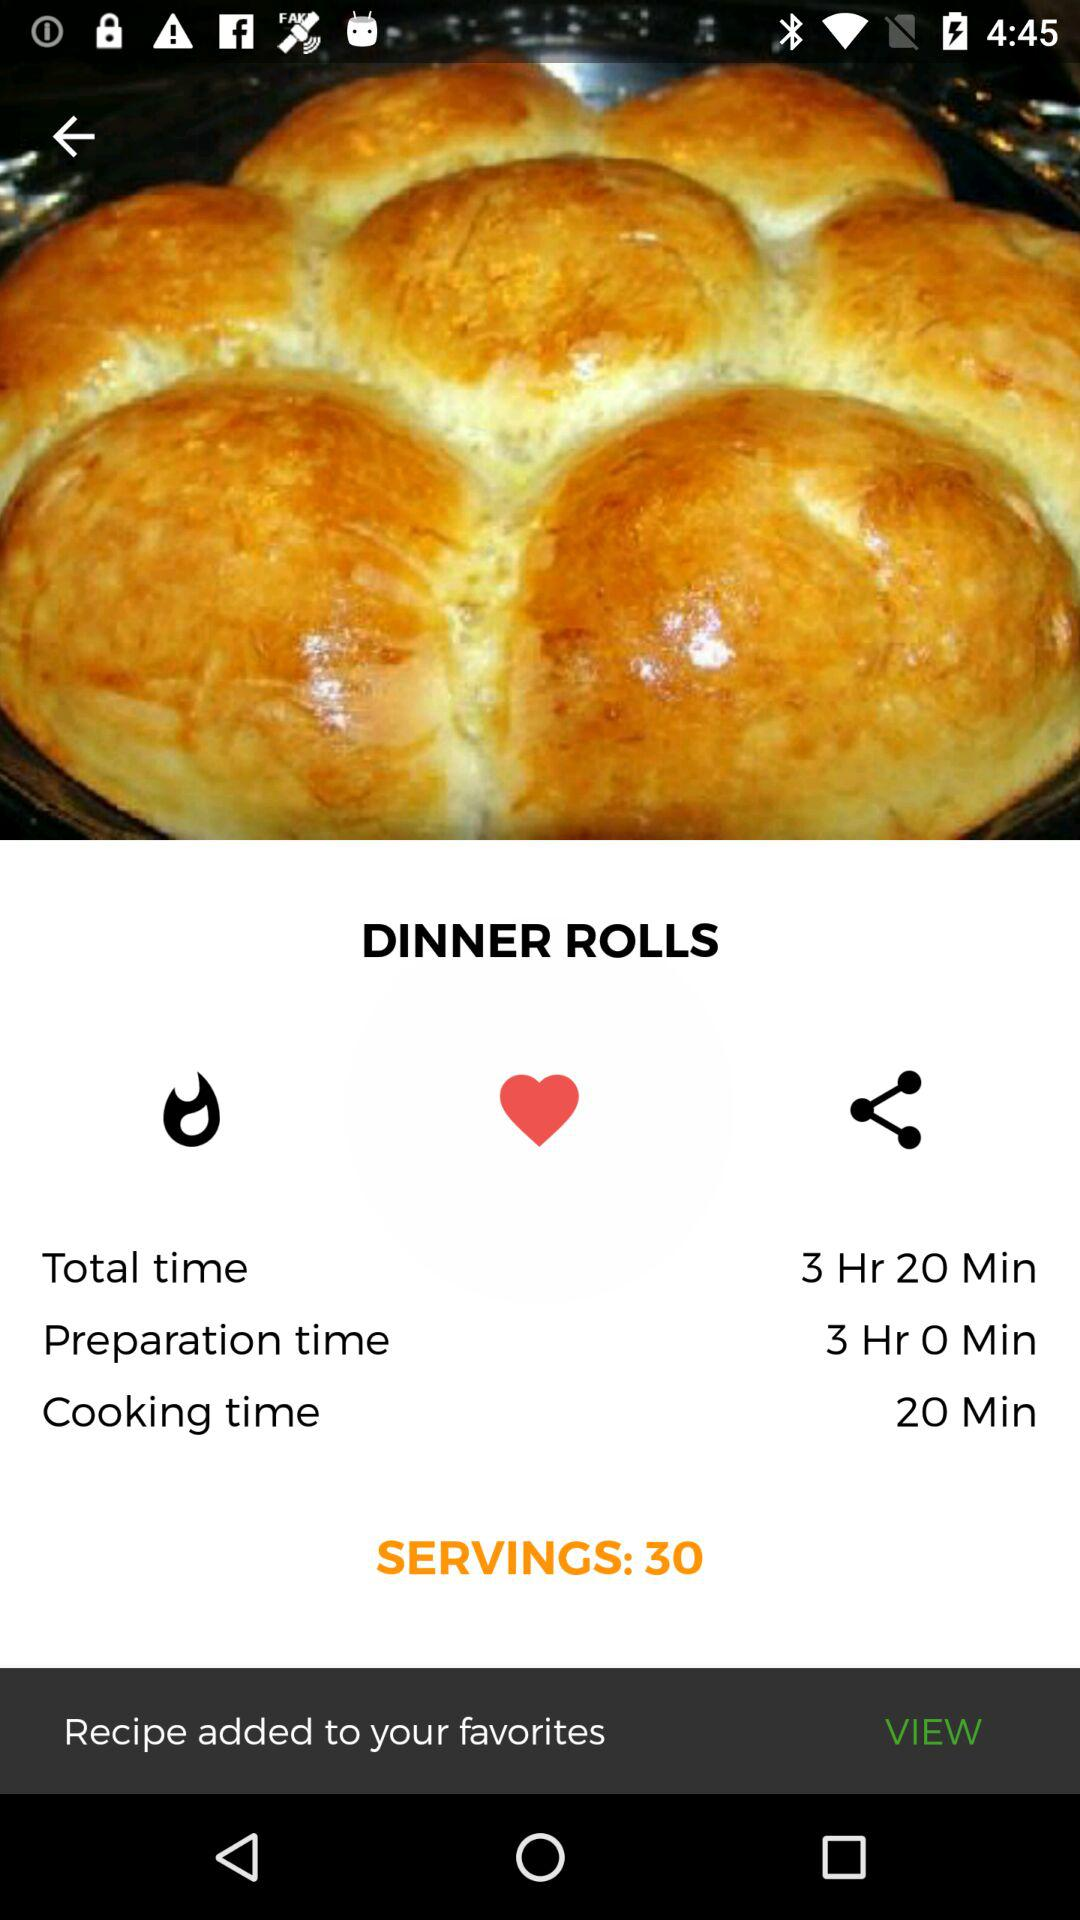What is the total time shown? The total time is 3 hours and 20 minutes. 